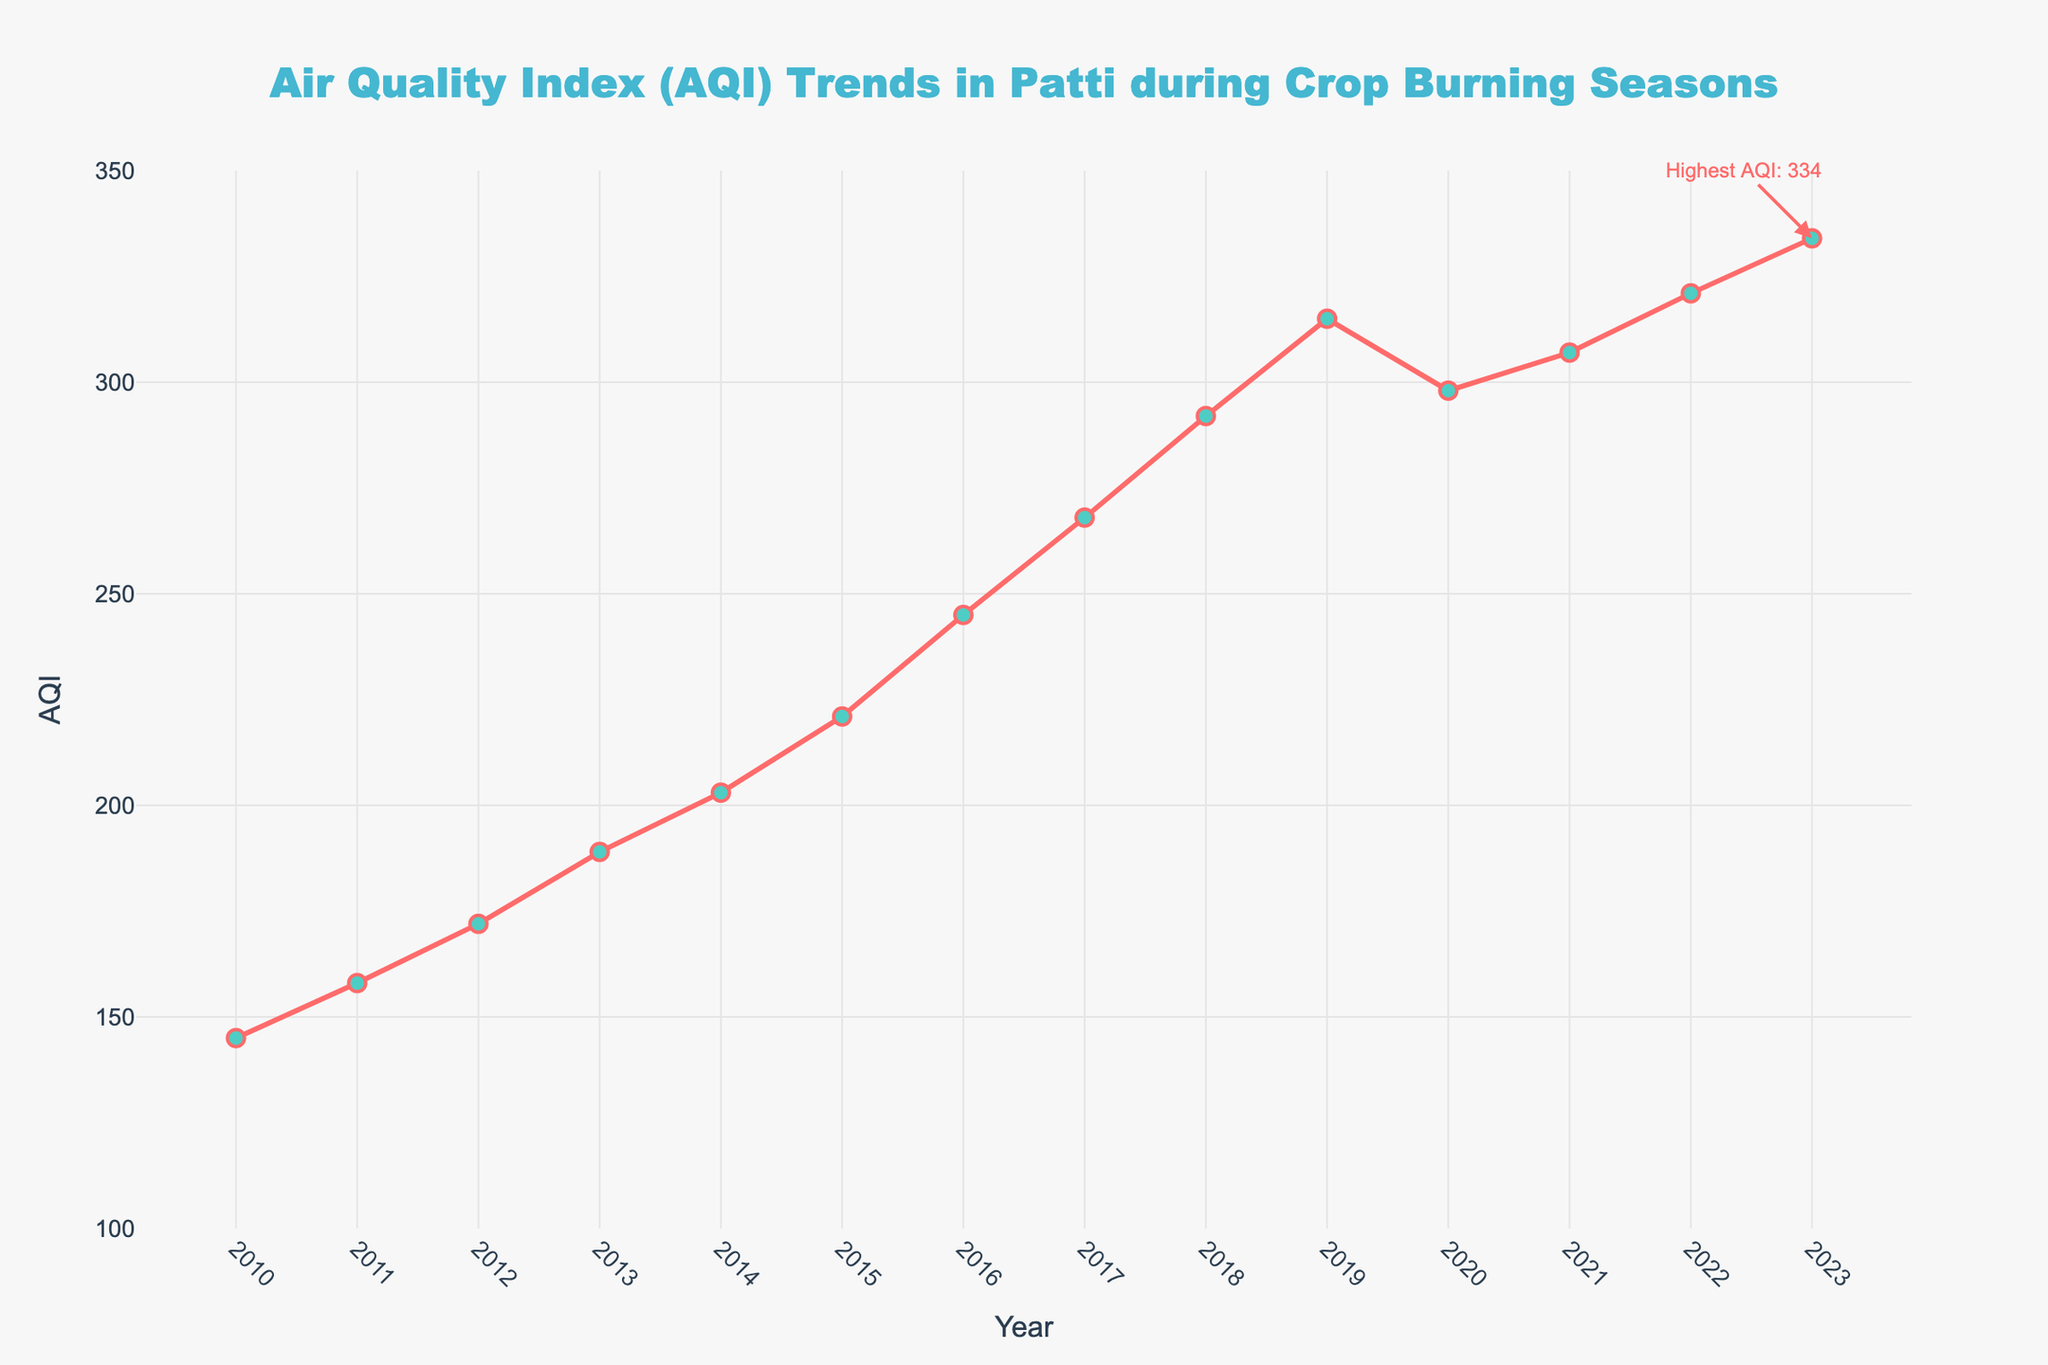What was the AQI in Patti in the year 2015? Locate the year 2015 on the x-axis and trace upwards to find the corresponding AQI value on the y-axis. The value is 221.
Answer: 221 In which year did Patti have the highest AQI, and what was the value? Identify the highest point on the graph, which is annotated as the highest AQI. The year is 2023, and the AQI is 334.
Answer: 2023, 334 How much did the AQI increase from 2010 to 2023? Subtract the AQI in 2010 from the AQI in 2023. The calculation is 334 - 145.
Answer: 189 What is the trend of the AQI in Patti from 2010 to 2023? Observe the general direction of the line from 2010 to 2023. The line consistently rises, indicating an upward trend.
Answer: Upward trend By how much did the AQI change between 2020 and 2021? Find the AQI values for 2020 and 2021 and subtract one from the other. The calculation is 307 - 298.
Answer: 9 Which years saw the AQI value cross 300 for the first time in Patti? Identify the year where the AQI value is greater than 300 for the first time. The year is 2019 with an AQI of 315.
Answer: 2019 How does the AQI in 2017 compare to the AQI in 2016? Compare the AQI values of 2017 and 2016. The AQI in 2017 (268) is higher than in 2016 (245).
Answer: Higher in 2017 What is the average AQI over the entire period from 2010 to 2023? Sum all the AQI values from 2010 to 2023 and divide by the number of years (14). The calculation is (145 + 158 + 172 + 189 + 203 + 221 + 245 + 268 + 292 + 315 + 298 + 307 + 321 + 334) / 14 = 248.5
Answer: 248.5 